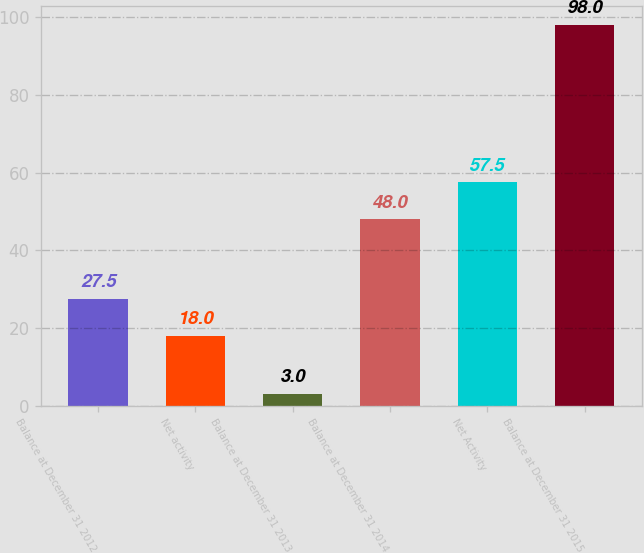<chart> <loc_0><loc_0><loc_500><loc_500><bar_chart><fcel>Balance at December 31 2012<fcel>Net activity<fcel>Balance at December 31 2013<fcel>Balance at December 31 2014<fcel>Net Activity<fcel>Balance at December 31 2015<nl><fcel>27.5<fcel>18<fcel>3<fcel>48<fcel>57.5<fcel>98<nl></chart> 